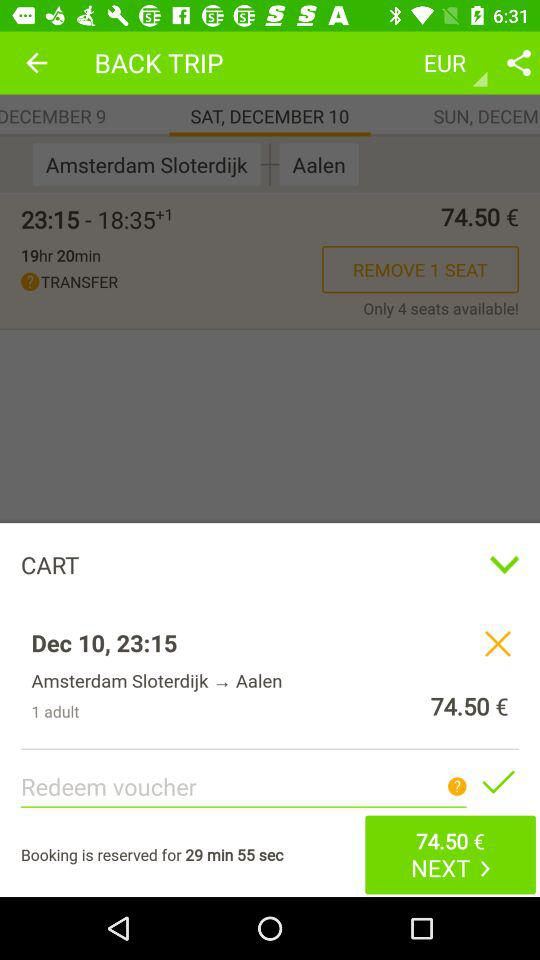What is the date of the trip from Amsterdam to Aalen? The date of the trip from Amsterdam to Aalen is Saturday, December 10. 